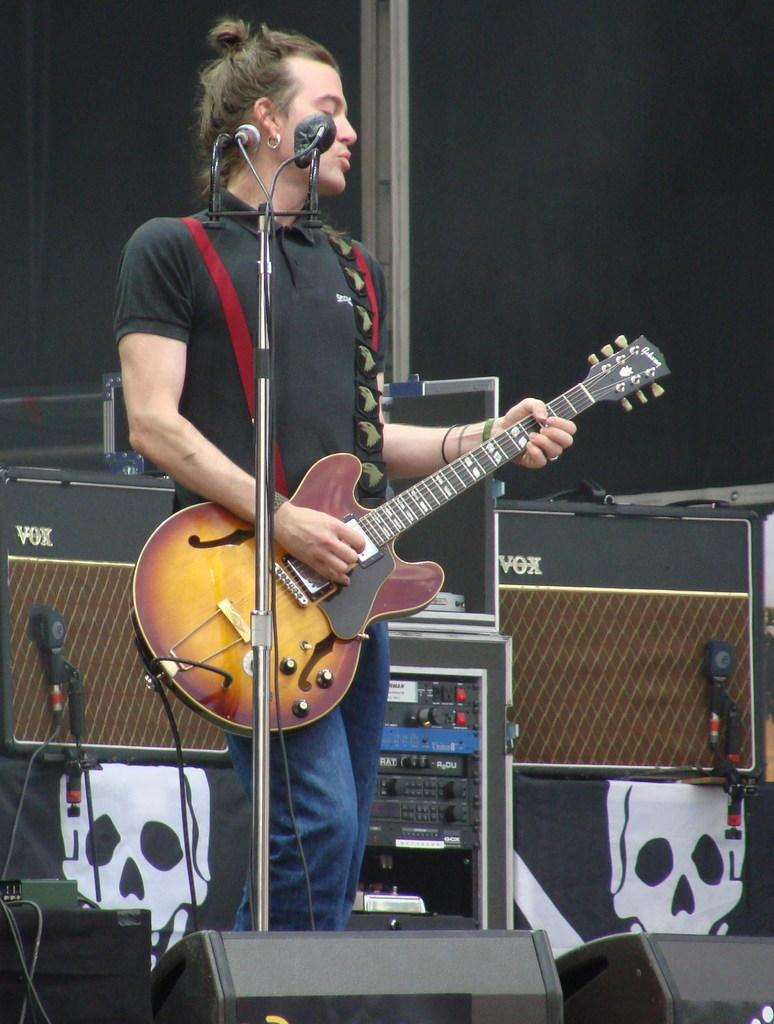What is the person in the image doing? The person is playing a guitar and singing. What is the person wearing? The person is wearing a black shirt. What object is the person in front of? The person is in front of a microphone. What can be seen behind the person? There are boxes behind the person. What type of cheese can be seen in the zoo in the image? There is no cheese or zoo present in the image; it features a person playing a guitar and singing in front of a microphone. 